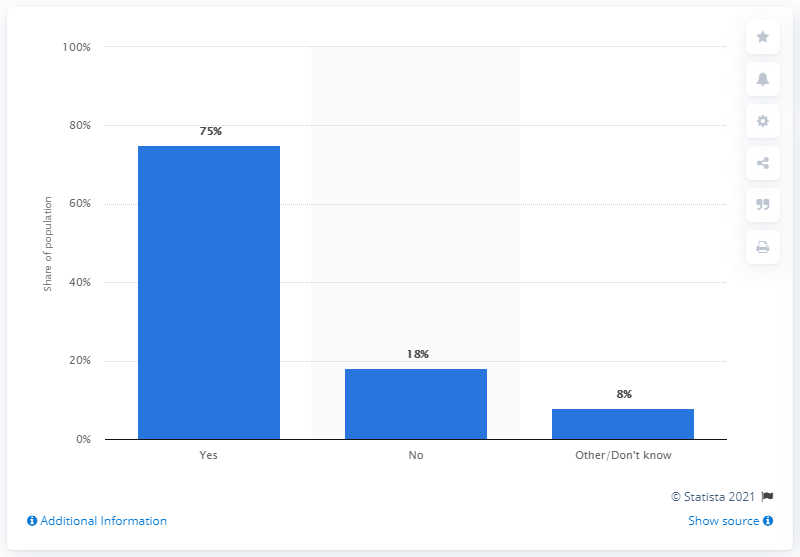Give some essential details in this illustration. Out of the total number of records, 18% did not fall into any category. Yes is the largest of the options provided. 